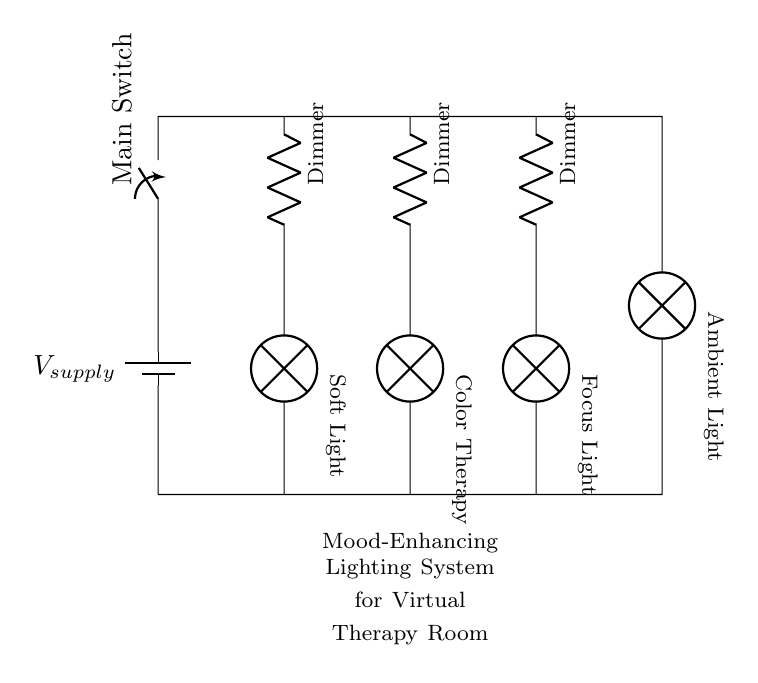What is the main purpose of the circuit? The circuit is designed for mood-enhancing lighting in a virtual therapy room, providing different lighting options to improve the atmosphere.
Answer: mood-enhancing lighting How many lamps are connected in this circuit? There are four lamps connected in parallel, corresponding to different lighting types: ambient, soft, color therapy, and focus light.
Answer: four lamps What are the types of dimmers used in the circuit? Each lamp has its own dimmer, allowing independent control of the brightness for ambient light, soft light, color therapy, and focus light.
Answer: independent dimmers What is the role of the switch in the circuit? The switch allows the user to turn the entire lighting system on or off, controlling the flow of electricity to all connected components simultaneously.
Answer: Main Switch How does a parallel circuit affect the operation of the lamps? In a parallel circuit, each lamp operates independently; if one lamp fails, the others continue to function as they are connected to the same voltage supply but on separate branches.
Answer: independent operation What component provides the voltage in this circuit? The battery serves as the voltage source, supplying power to the lamps and dimmers across the circuit.
Answer: battery 